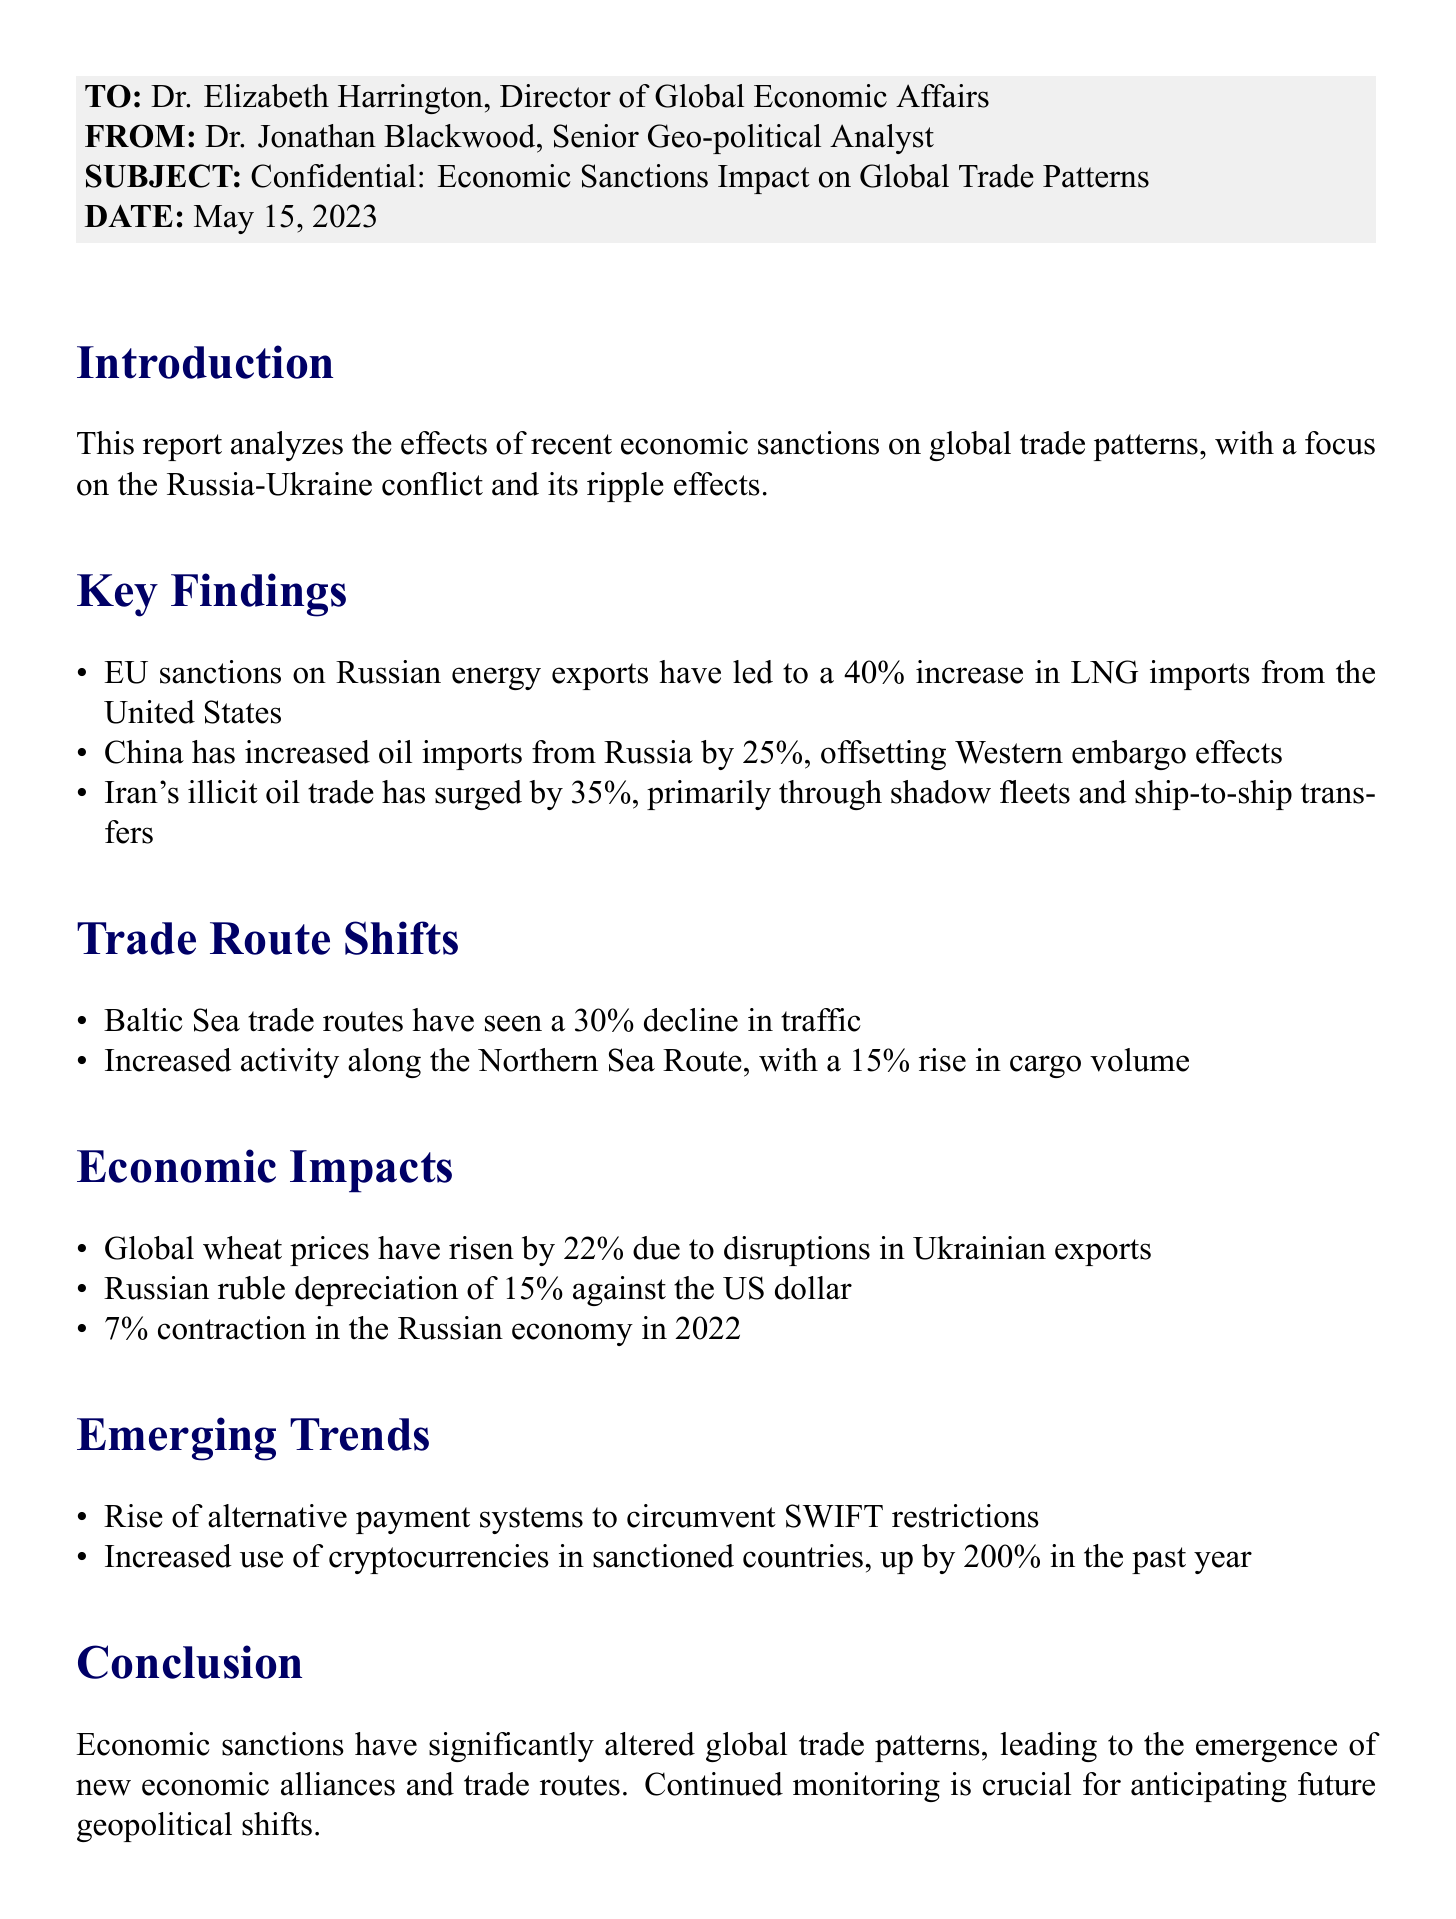What is the primary focus of the report? The report analyzes the effects of economic sanctions on global trade patterns, particularly relating to the Russia-Ukraine conflict.
Answer: Russia-Ukraine conflict What is the increase in LNG imports from the United States due to EU sanctions? The document states that EU sanctions on Russian energy exports have led to a specific increase in LNG imports from the United States.
Answer: 40% What has happened to oil imports from Russia by China? It notes that China has increased its oil imports from Russia by a certain percentage to offset Western embargo effects.
Answer: 25% What percentage has global wheat prices risen? This percentage indicates the economic impact of sanctions on agricultural exports from Ukraine.
Answer: 22% What was the contraction percentage of the Russian economy in 2022? The report provides information on the economic performance of Russia amidst sanctions by mentioning this contraction rate.
Answer: 7% Which trade route experienced a decline in traffic? It identifies a specific geographic area where trade activity has decreased significantly.
Answer: Baltic Sea What is the increase in the use of cryptocurrencies in sanctioned countries? The document reflects an emerging trend in financial practices in these nations, represented by this significant increase.
Answer: 200% What is the depreciation percentage of the Russian ruble against the US dollar? The document quantifies the economic impact on the currency amid sanctions.
Answer: 15% What trade route saw a rise in cargo volume? It mentions a specific route that has become more active due to changes in global trade dynamics.
Answer: Northern Sea Route 